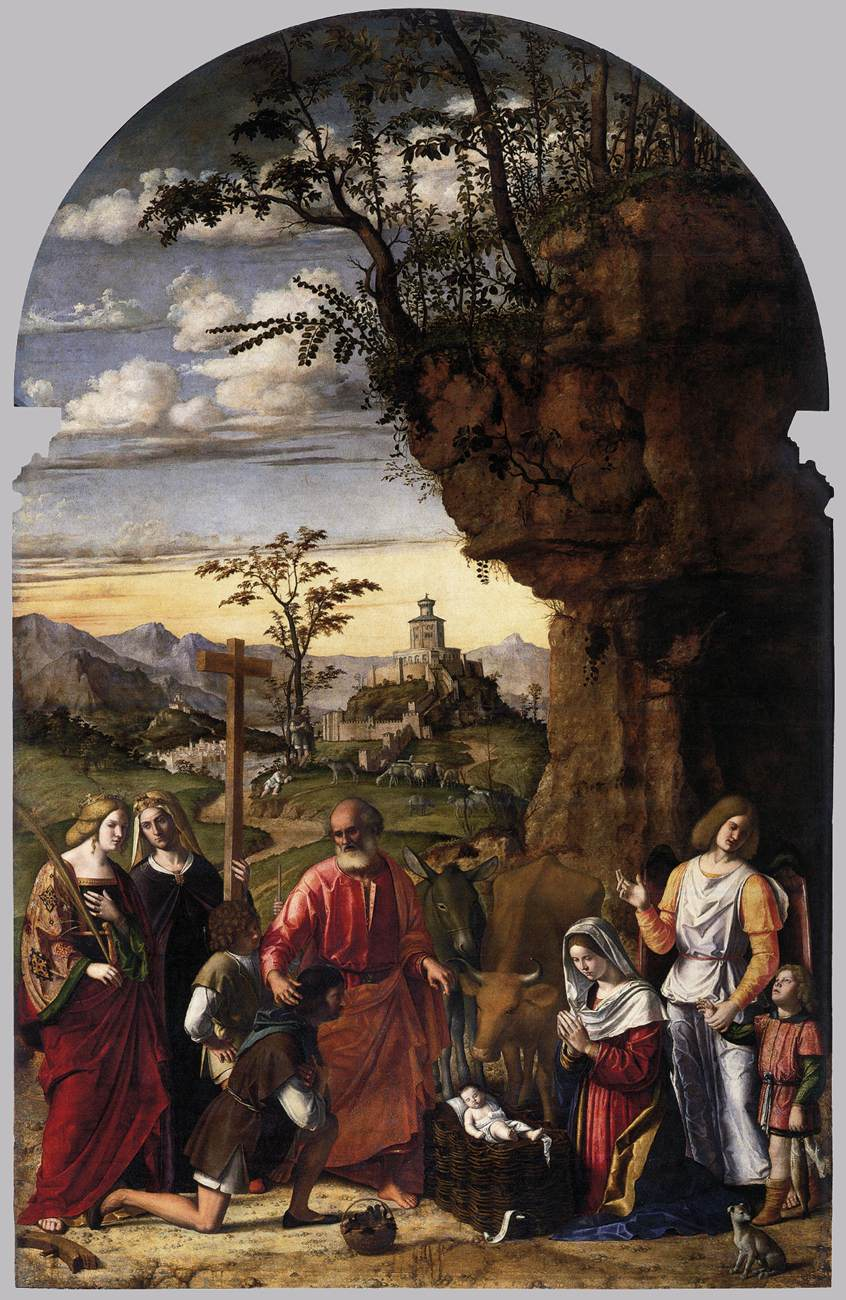Can you elaborate on the elements of the picture provided? This image is a captivating Renaissance oil painting depicting 'The Adoration of the Christ Child'. The scene unfolds within a picturesque landscape featuring a towering cliff to the right and a distant town to the left, adding depth and perspective. The focal point is a group of individuals adorned in vibrant, ornate attire, gathering with reverence around a baby in a basket. Detailed and lifelike, the painting captures the awe-struck expressions of each figure. Rooted in the religious art genre prevalent during the Renaissance, the artist's adept use of color and meticulous detail not only underscores the scene's religious import but also reflects contemporary cultural and artistic norms. The composition, color palette, and intricate detail collectively enhance the painting's visual allure and historical significance, making it a remarkable piece of enduring legacy. 